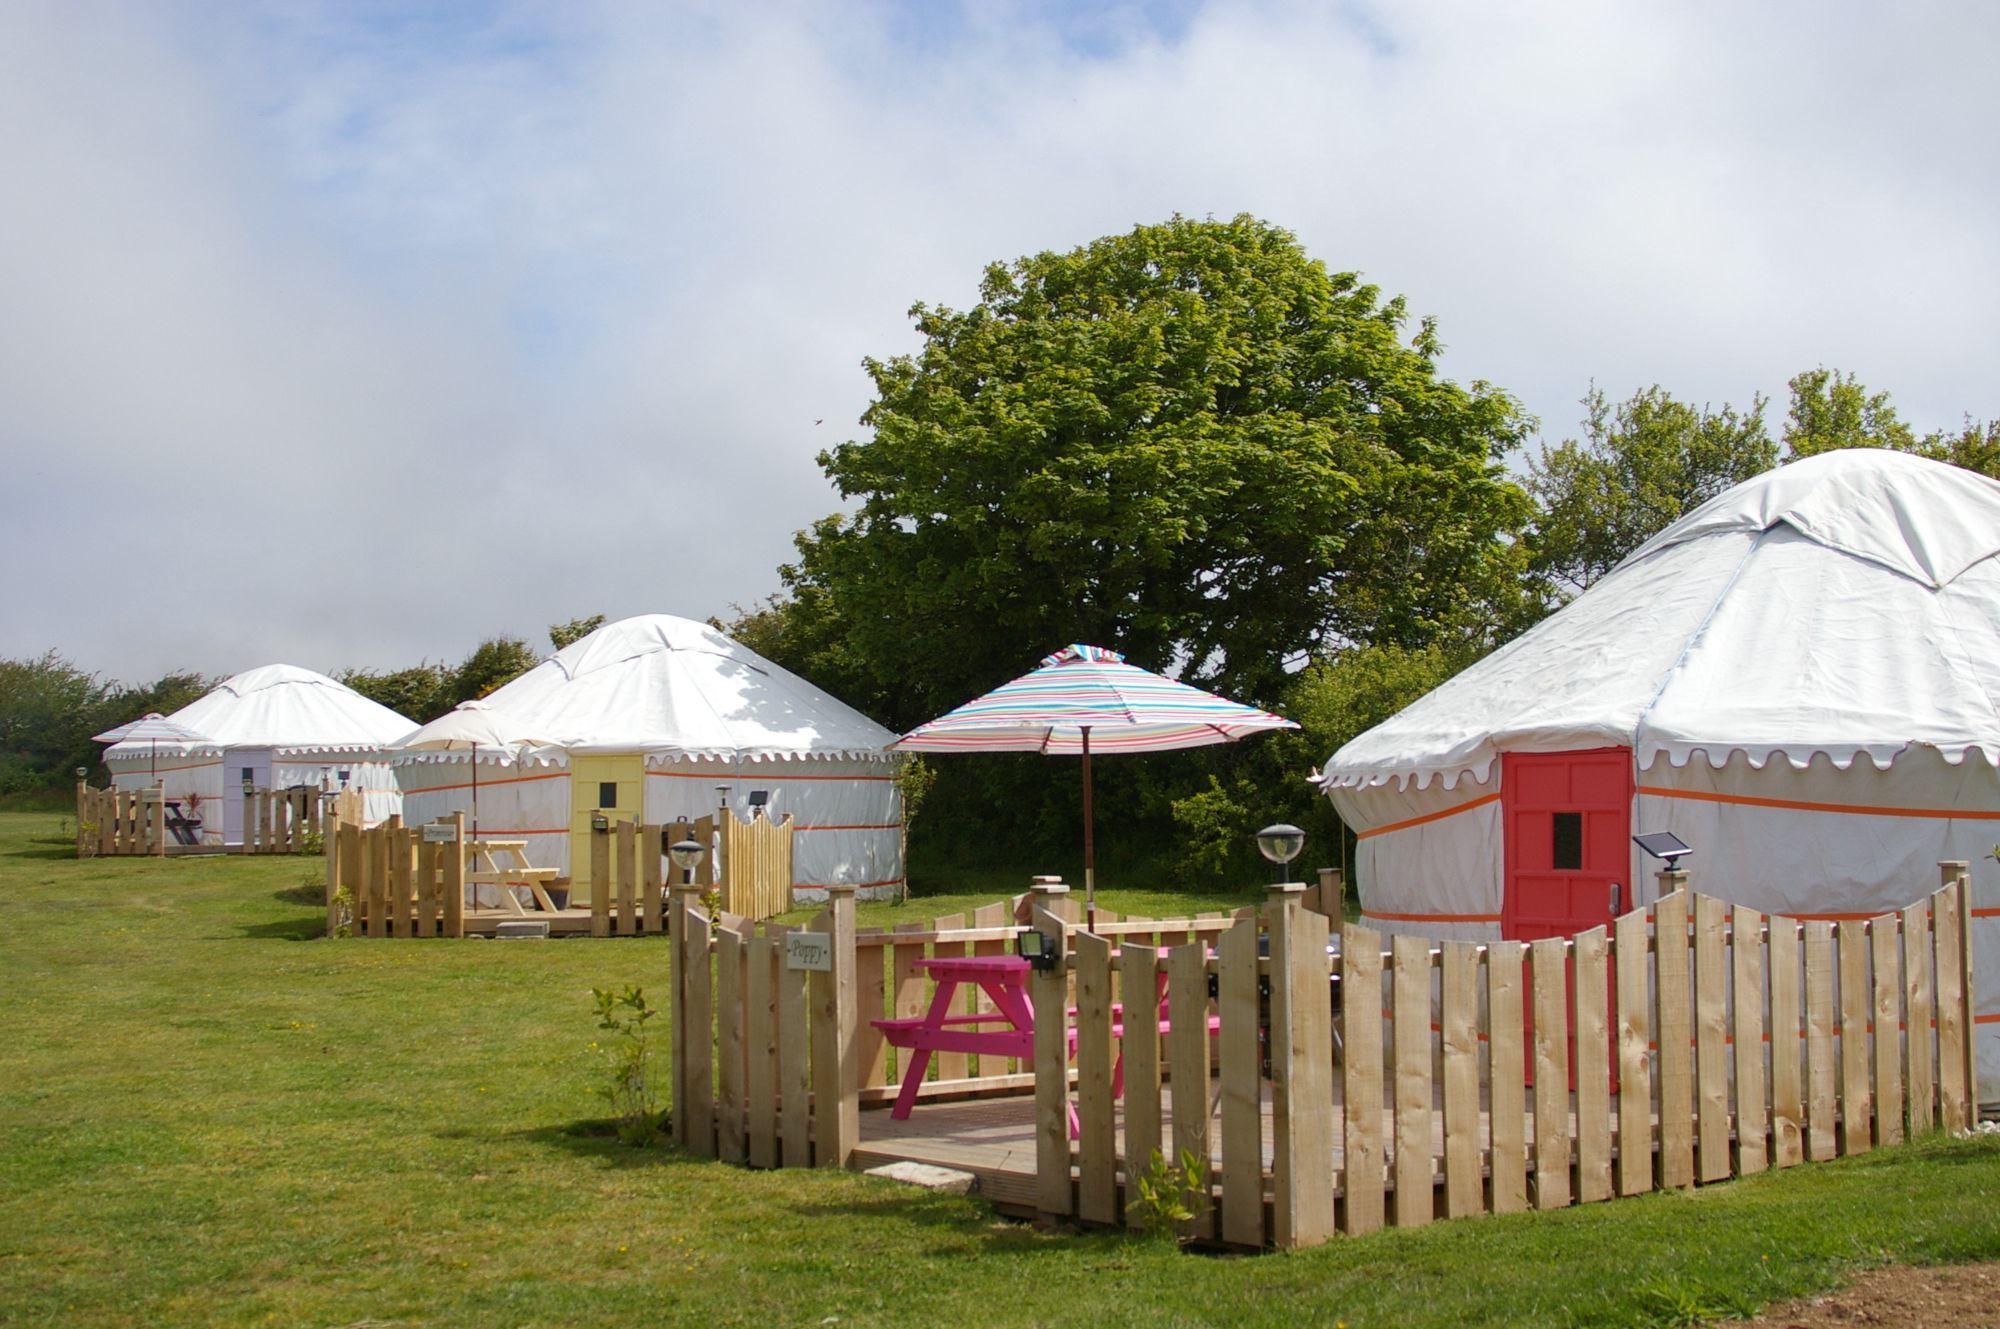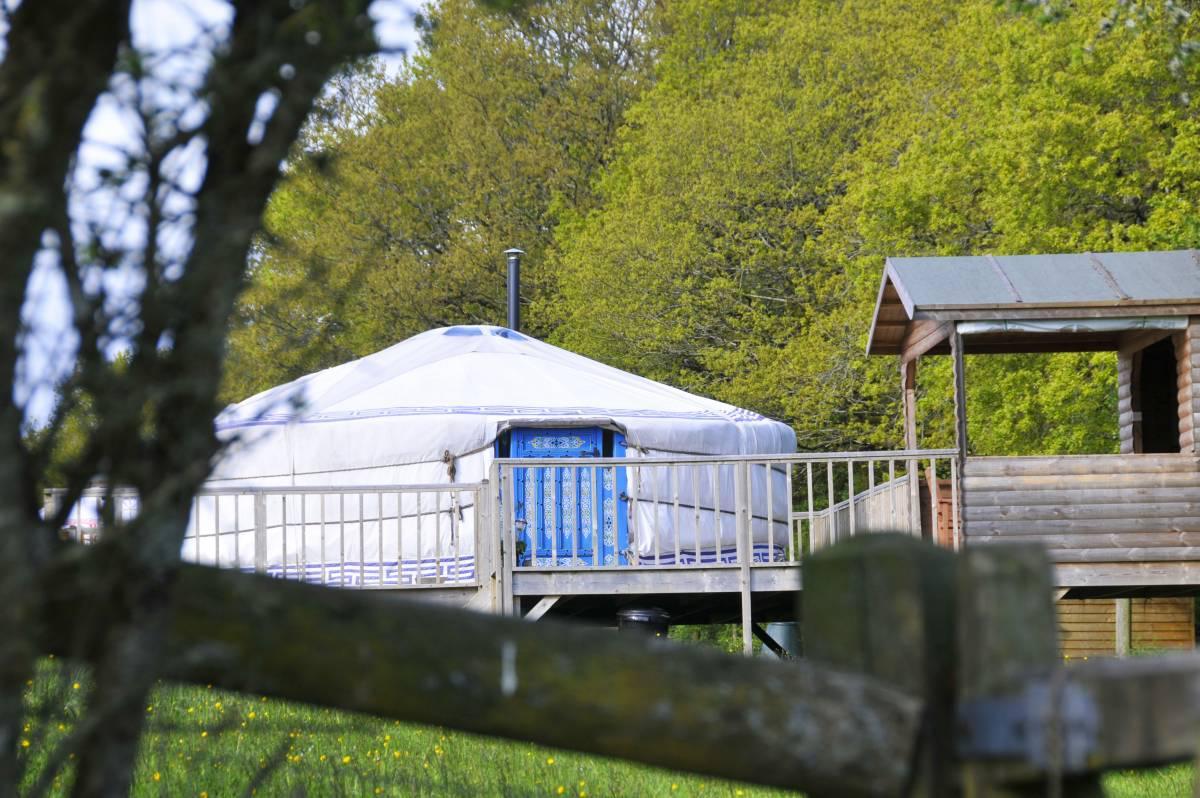The first image is the image on the left, the second image is the image on the right. For the images displayed, is the sentence "In one image, a yurt sits on a raised deck with wooden fencing, while the other image shows one or more yurts with outdoor table seating." factually correct? Answer yes or no. Yes. 